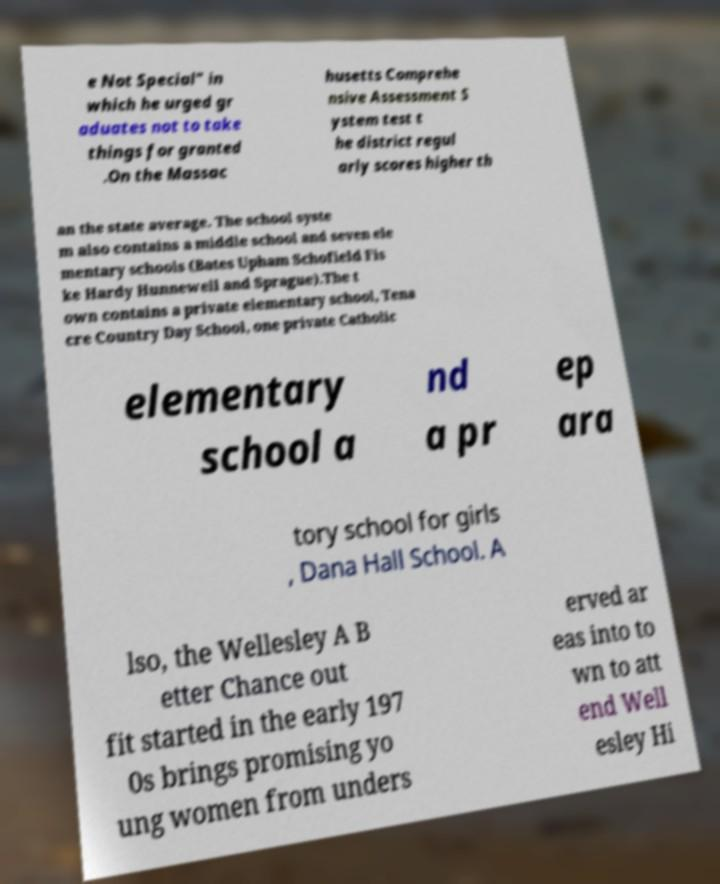For documentation purposes, I need the text within this image transcribed. Could you provide that? e Not Special" in which he urged gr aduates not to take things for granted .On the Massac husetts Comprehe nsive Assessment S ystem test t he district regul arly scores higher th an the state average. The school syste m also contains a middle school and seven ele mentary schools (Bates Upham Schofield Fis ke Hardy Hunnewell and Sprague).The t own contains a private elementary school, Tena cre Country Day School, one private Catholic elementary school a nd a pr ep ara tory school for girls , Dana Hall School. A lso, the Wellesley A B etter Chance out fit started in the early 197 0s brings promising yo ung women from unders erved ar eas into to wn to att end Well esley Hi 